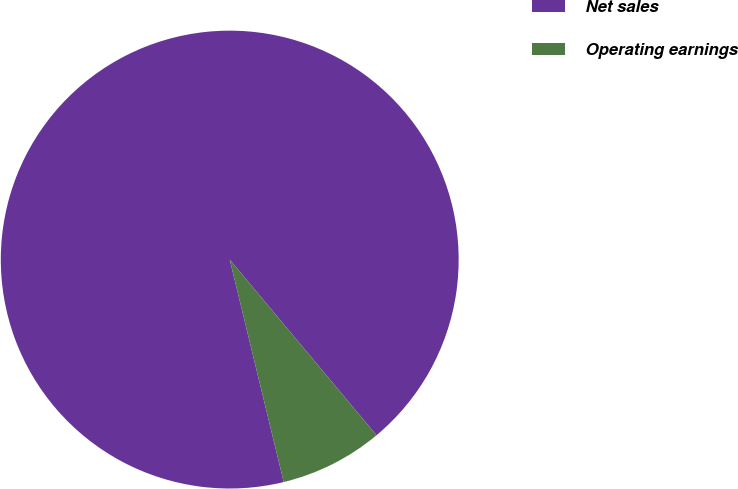<chart> <loc_0><loc_0><loc_500><loc_500><pie_chart><fcel>Net sales<fcel>Operating earnings<nl><fcel>92.71%<fcel>7.29%<nl></chart> 